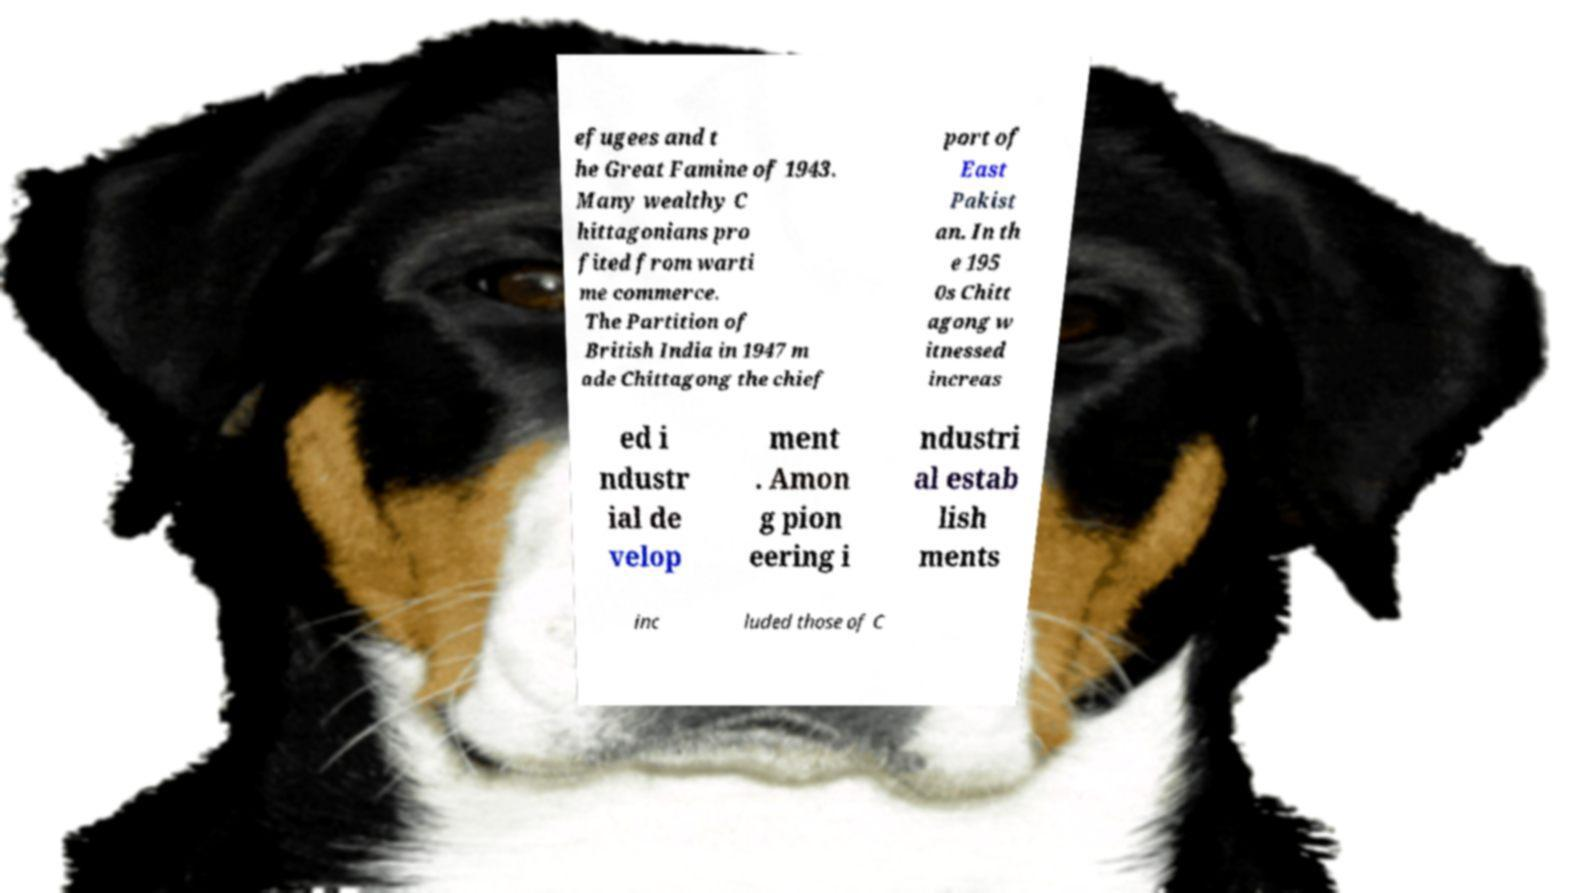Please read and relay the text visible in this image. What does it say? efugees and t he Great Famine of 1943. Many wealthy C hittagonians pro fited from warti me commerce. The Partition of British India in 1947 m ade Chittagong the chief port of East Pakist an. In th e 195 0s Chitt agong w itnessed increas ed i ndustr ial de velop ment . Amon g pion eering i ndustri al estab lish ments inc luded those of C 